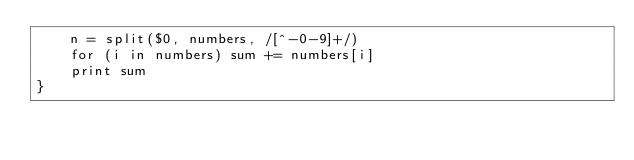Convert code to text. <code><loc_0><loc_0><loc_500><loc_500><_Awk_>    n = split($0, numbers, /[^-0-9]+/)
    for (i in numbers) sum += numbers[i]
    print sum
}
</code> 